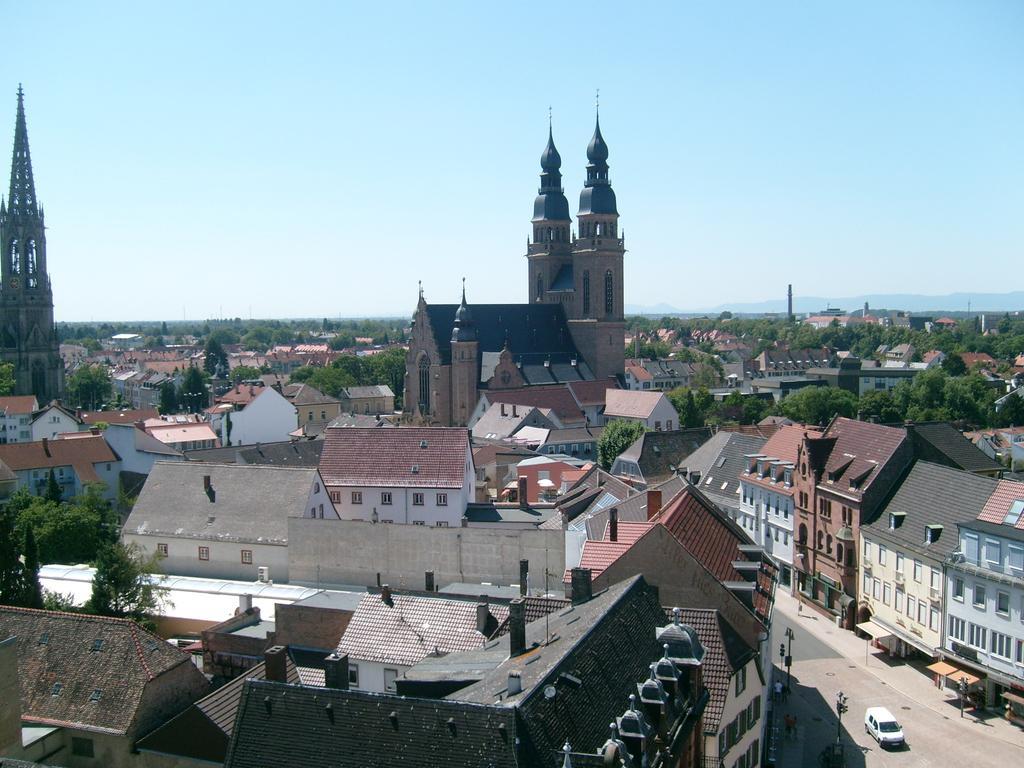Describe this image in one or two sentences. In this image I can see few buildings in white, cream and brown color and I can also see few vehicles, light poles, trees in green color and the sky is in blue and white color. 